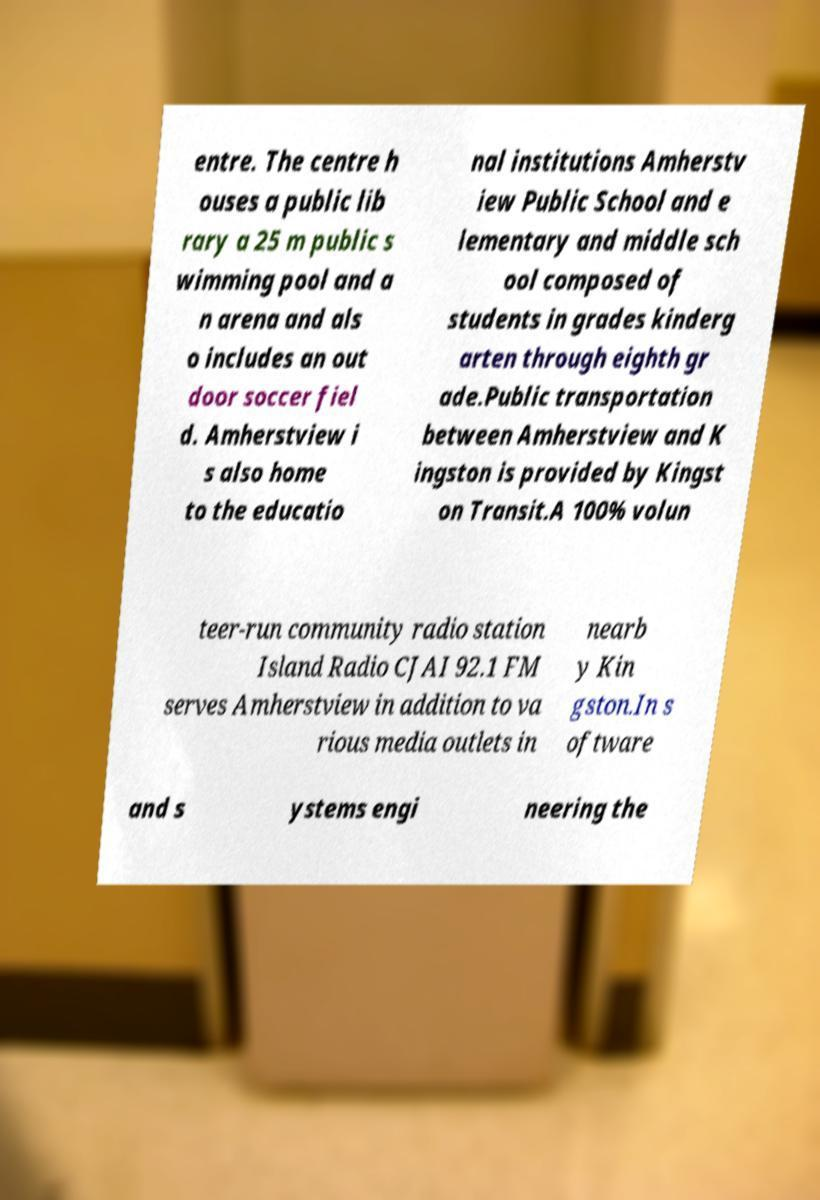Could you extract and type out the text from this image? entre. The centre h ouses a public lib rary a 25 m public s wimming pool and a n arena and als o includes an out door soccer fiel d. Amherstview i s also home to the educatio nal institutions Amherstv iew Public School and e lementary and middle sch ool composed of students in grades kinderg arten through eighth gr ade.Public transportation between Amherstview and K ingston is provided by Kingst on Transit.A 100% volun teer-run community radio station Island Radio CJAI 92.1 FM serves Amherstview in addition to va rious media outlets in nearb y Kin gston.In s oftware and s ystems engi neering the 